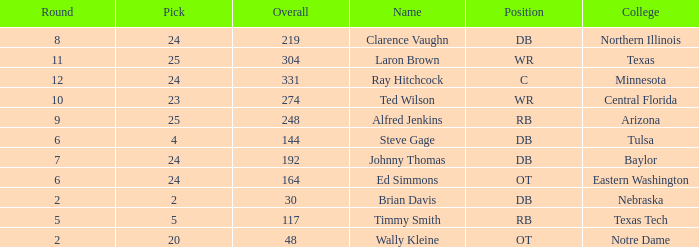What are the total rounds for the texas college and has a pick smaller than 25? 0.0. 